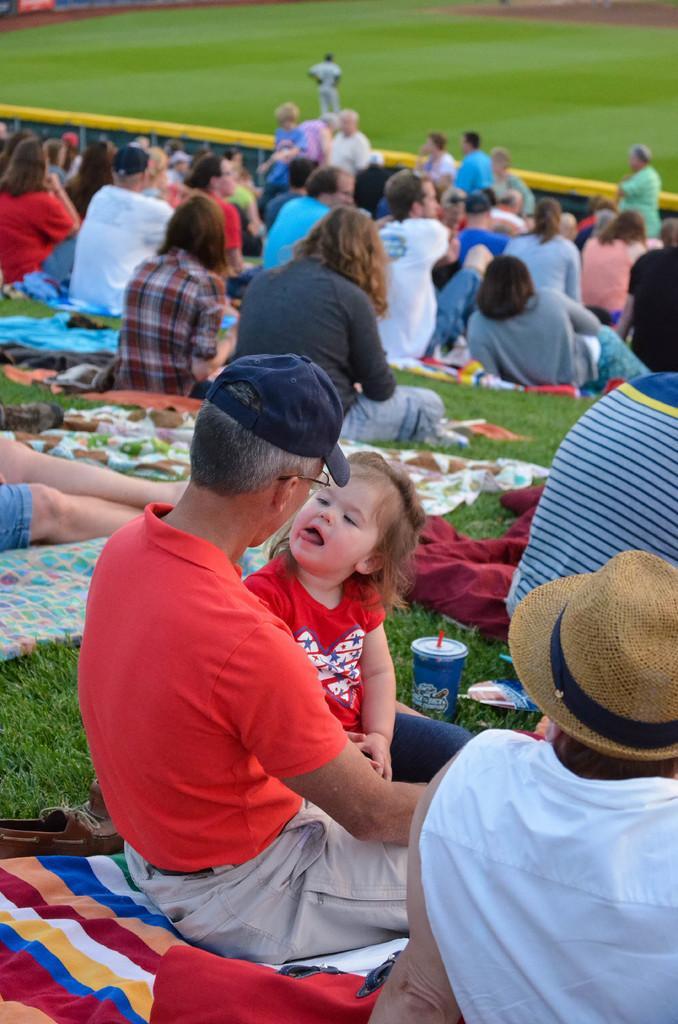Describe this image in one or two sentences. In this image, we can see a group of people are sitting. Here there are few objects are placed on the grass. Top of the image, we can see the ground and people. Few people are standing. 